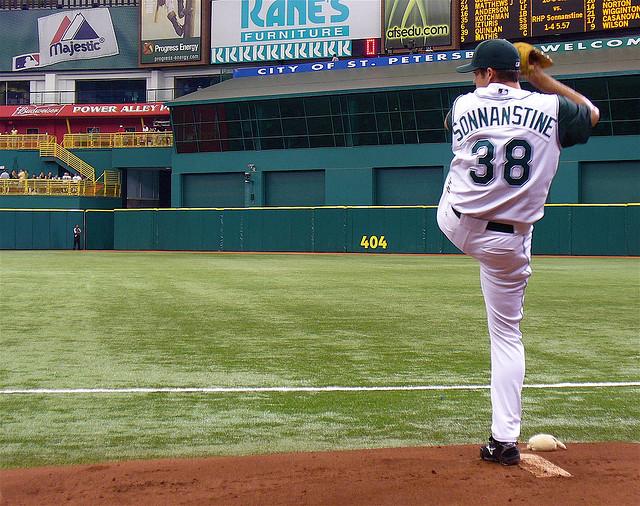What game is being played?
Keep it brief. Baseball. Does it look like this man only has one leg?
Quick response, please. Yes. What is the men's Jersey number?
Answer briefly. 38. 